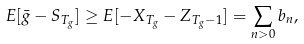<formula> <loc_0><loc_0><loc_500><loc_500>E [ \bar { g } - S _ { T _ { g } } ] \geq E [ - X _ { T _ { g } } - Z _ { T _ { g } - 1 } ] = \sum _ { n > 0 } b _ { n } ,</formula> 